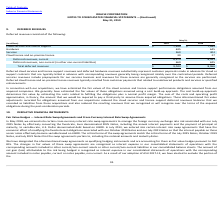According to Oracle Corporation's financial document, How does the cost build-up approach determine fair value? The cost build-up approach determines fair value by estimating the costs related to fulfilling the obligations plus a normal profit margin.. The document states: "bligations assumed using a cost build-up approach. The cost build-up approach determines fair value by estimating the costs related to fulfilling the ..." Also, When are deferred services revenue recognized? Deferred services revenues include prepayments for our services business and revenues for these services are generally recognized as the services are performed.. The document states: "g recognized ratably over the contractual periods. Deferred services revenues include prepayments for our services business and revenues for these ser..." Also, How did the fair value adjustments recorded for obligations affect the cloud services and license support deferred revenue balances? These aforementioned fair value adjustments recorded for obligations assumed from our acquisitions reduced the cloud services and license support deferred revenues balances that we recorded as liabilities from these acquisitions. The document states: "third party to assume these acquired obligations. These aforementioned fair value adjustments recorded for obligations assumed from our acquisitions r..." Also, can you calculate: What is the current deferred revenue in 2019 as a percentage of total deferred revenue? Based on the calculation: 8,374/9,043 , the result is 92.6 (percentage). This is based on the information: "Total deferred revenues $ 9,043 $ 8,966 Deferred revenues, current 8,374 8,341..." The key data points involved are: 8,374, 9,043. Also, can you calculate: What is the average cloud services and license support deferred revenue from 2018 to 2019? To answer this question, I need to perform calculations using the financial data. The calculation is: (7,265+7,340)/2, which equals 7302.5 (in millions). This is based on the information: "Cloud services and license support $ 7,340 $ 7,265 Cloud services and license support $ 7,340 $ 7,265..." The key data points involved are: 7,265, 7,340. Also, can you calculate: What is the difference in the total deferred revenues from 2018 to 2019? Based on the calculation: 9,043-8,966, the result is 77 (in millions). This is based on the information: "Total deferred revenues $ 9,043 $ 8,966 Total deferred revenues $ 9,043 $ 8,966..." The key data points involved are: 8,966, 9,043. 